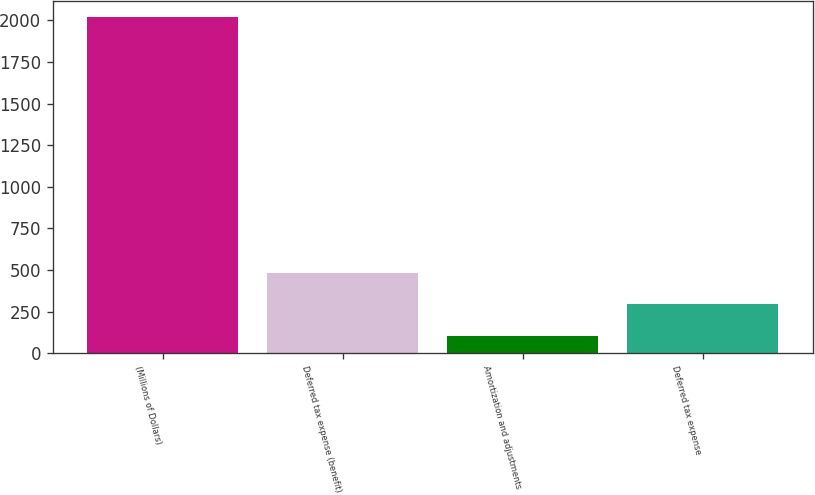<chart> <loc_0><loc_0><loc_500><loc_500><bar_chart><fcel>(Millions of Dollars)<fcel>Deferred tax expense (benefit)<fcel>Amortization and adjustments<fcel>Deferred tax expense<nl><fcel>2018<fcel>485.2<fcel>102<fcel>293.6<nl></chart> 